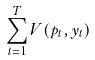Convert formula to latex. <formula><loc_0><loc_0><loc_500><loc_500>\sum _ { t = 1 } ^ { T } V ( p _ { t } , y _ { t } )</formula> 